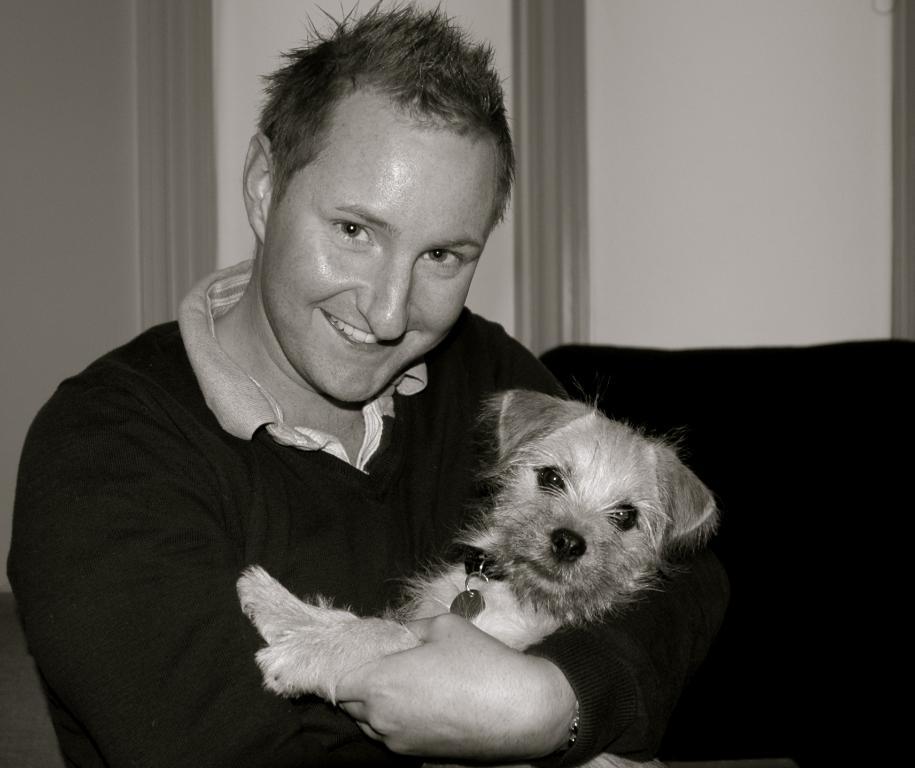Can you describe this image briefly? In this image I can see a man and he is holding a dog. I can also see a smile on his face. 